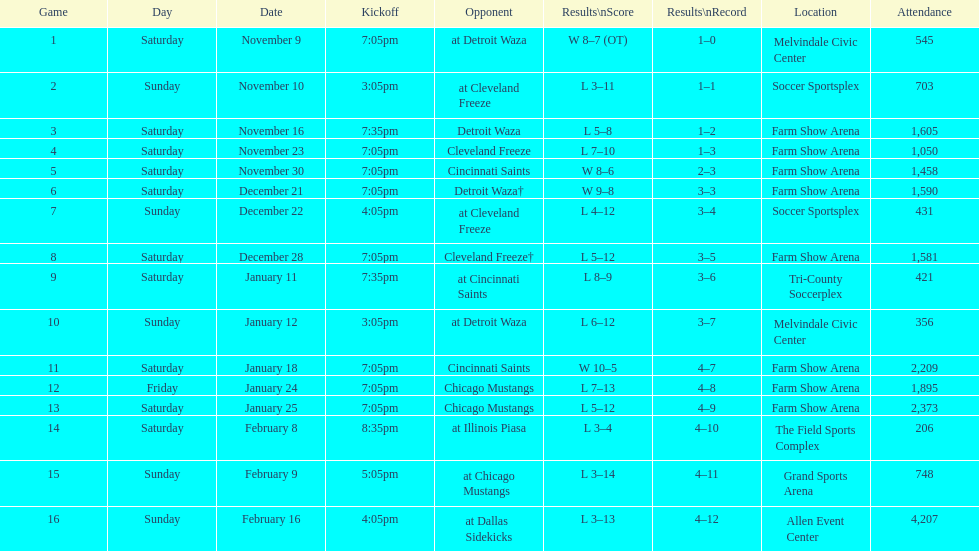How many times did the team play at home but did not win? 5. 